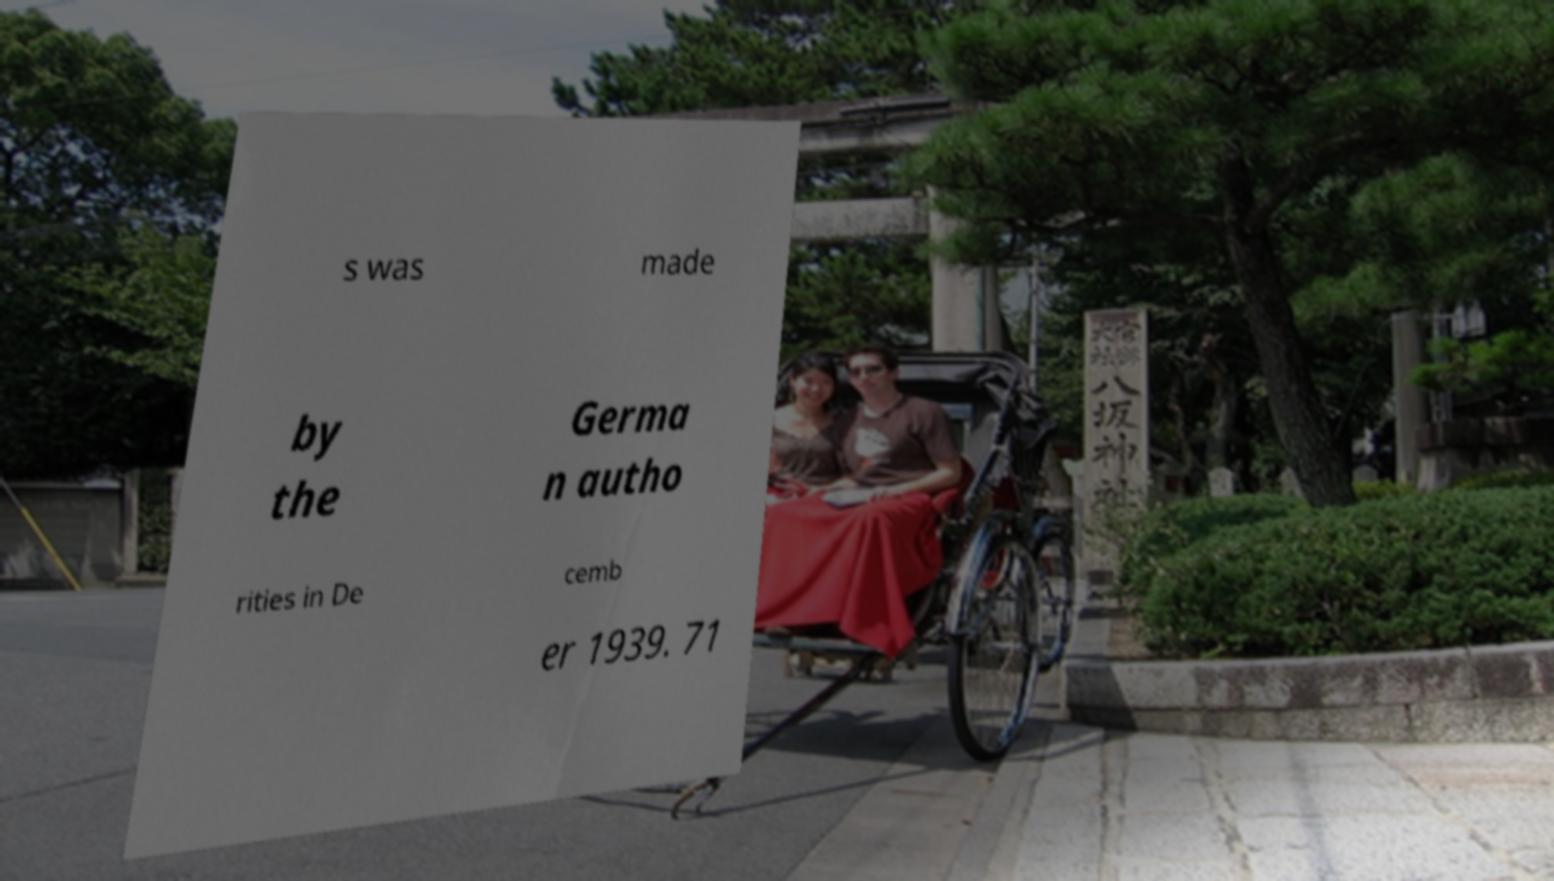There's text embedded in this image that I need extracted. Can you transcribe it verbatim? s was made by the Germa n autho rities in De cemb er 1939. 71 